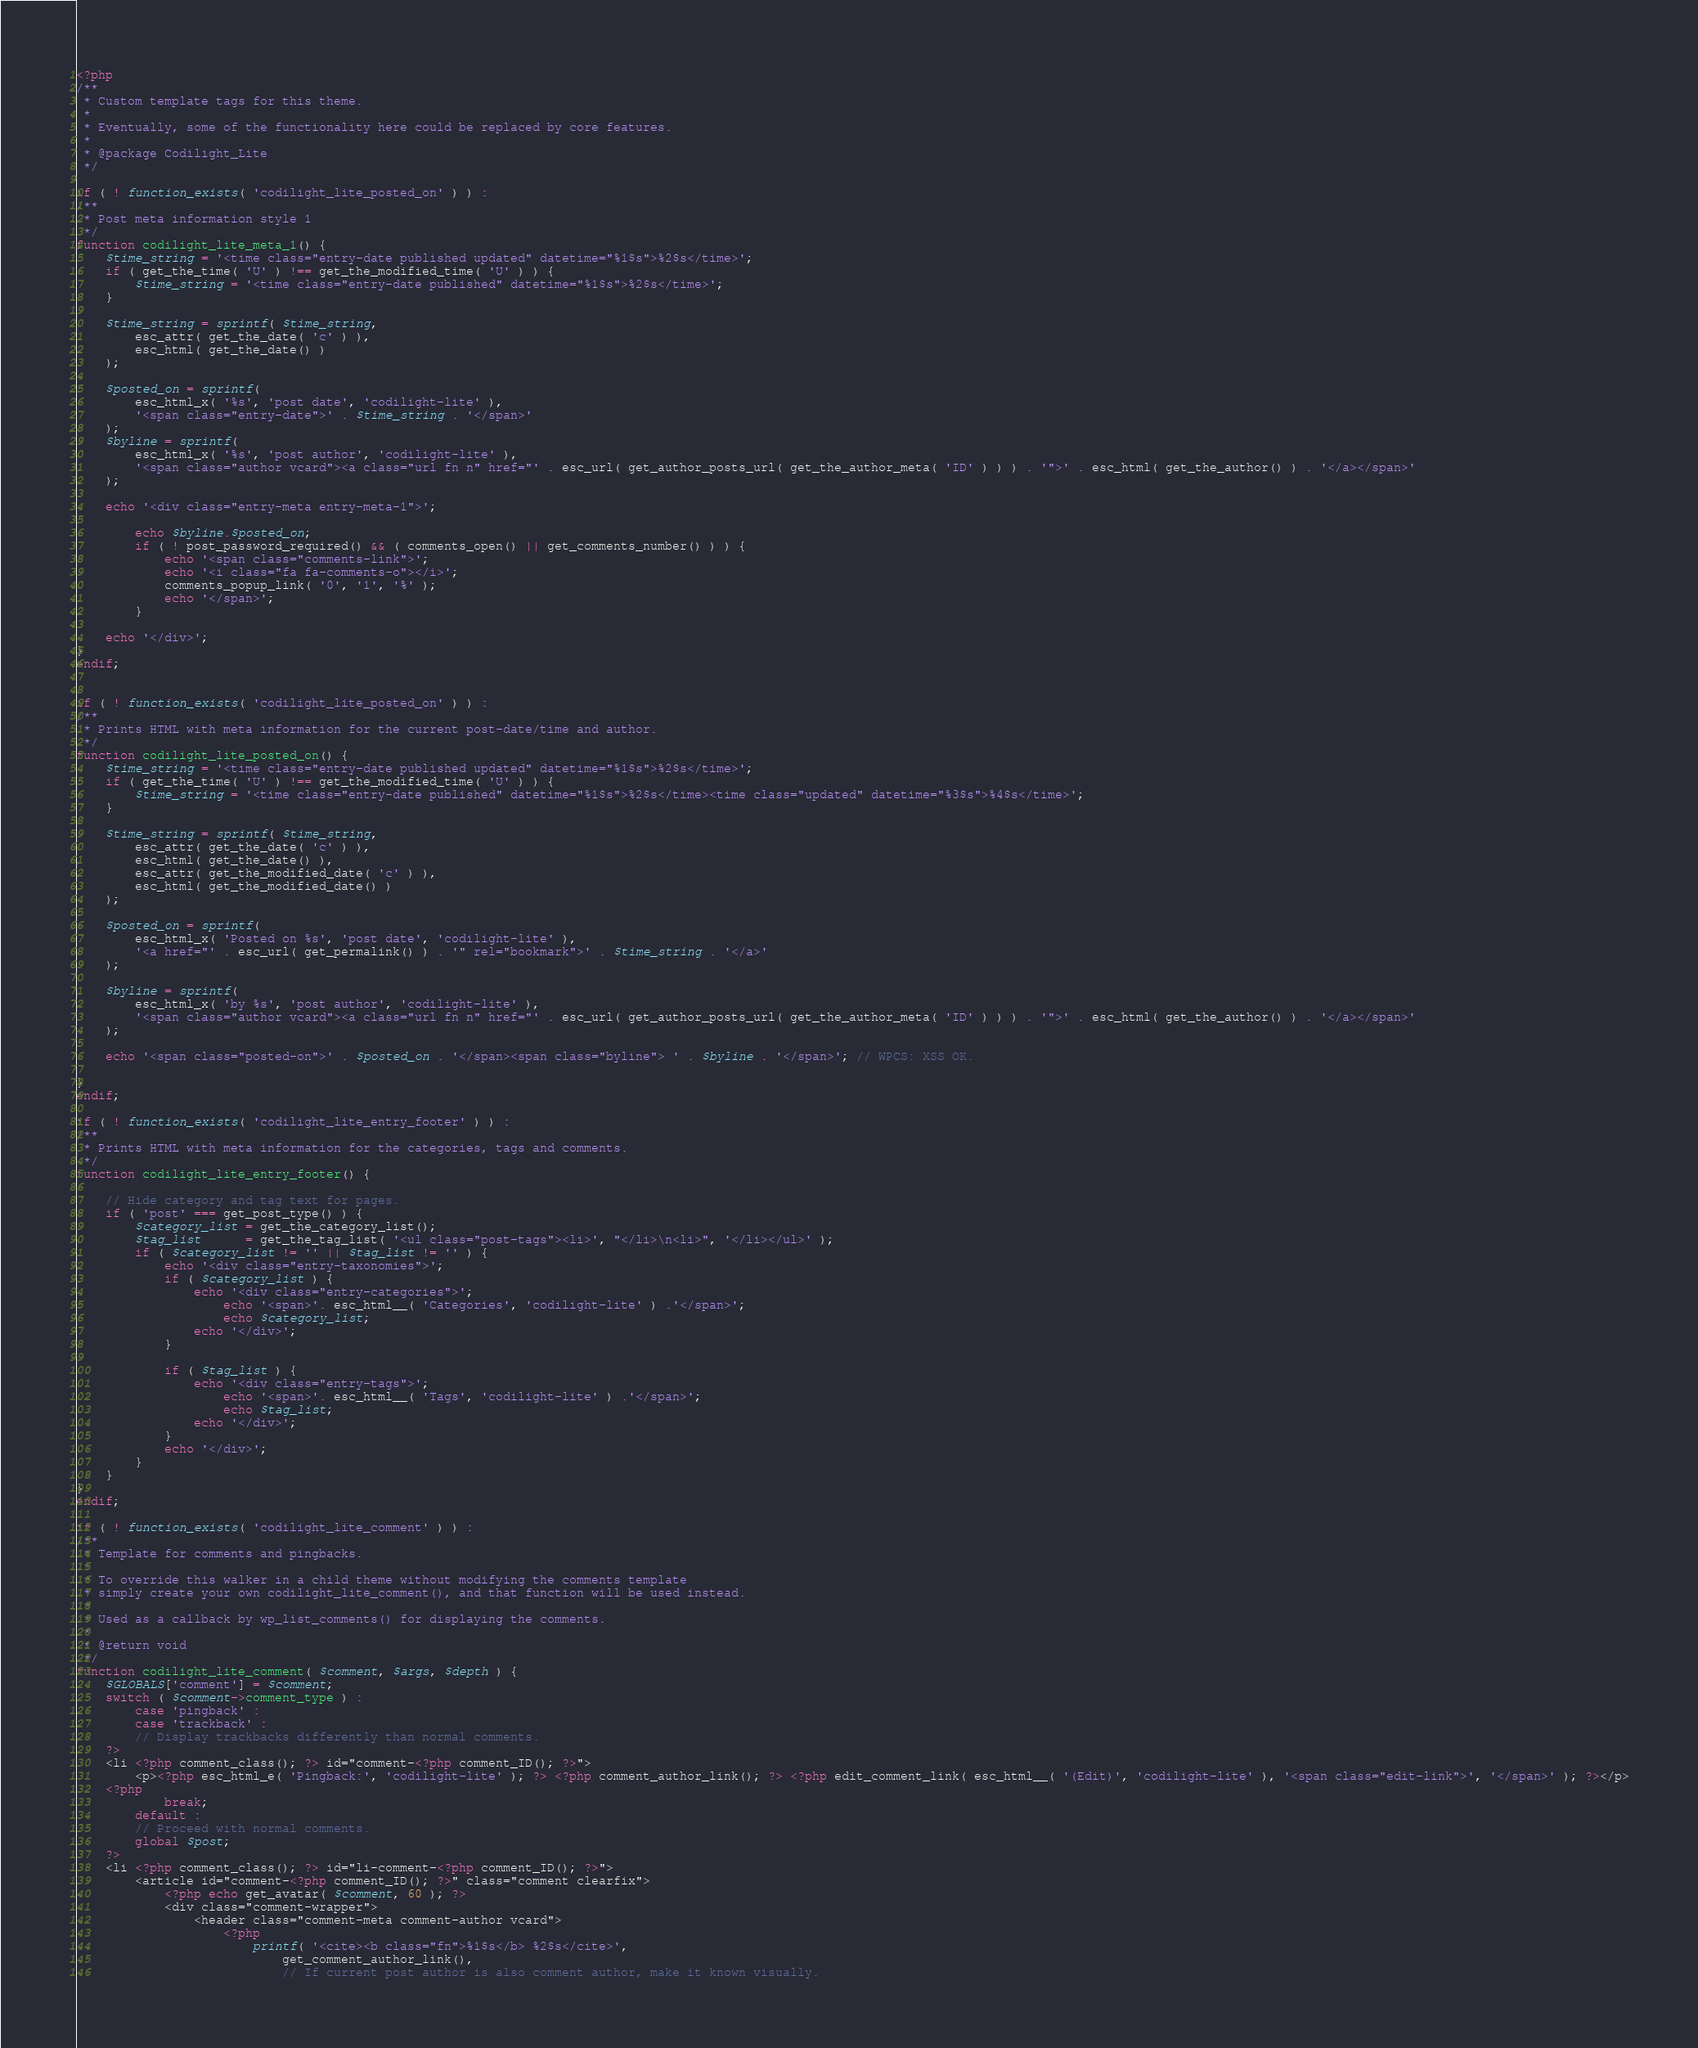Convert code to text. <code><loc_0><loc_0><loc_500><loc_500><_PHP_><?php
/**
 * Custom template tags for this theme.
 *
 * Eventually, some of the functionality here could be replaced by core features.
 *
 * @package Codilight_Lite
 */

if ( ! function_exists( 'codilight_lite_posted_on' ) ) :
/**
 * Post meta information style 1
 */
function codilight_lite_meta_1() {
	$time_string = '<time class="entry-date published updated" datetime="%1$s">%2$s</time>';
	if ( get_the_time( 'U' ) !== get_the_modified_time( 'U' ) ) {
		$time_string = '<time class="entry-date published" datetime="%1$s">%2$s</time>';
	}

	$time_string = sprintf( $time_string,
		esc_attr( get_the_date( 'c' ) ),
		esc_html( get_the_date() )
	);

	$posted_on = sprintf(
		esc_html_x( '%s', 'post date', 'codilight-lite' ),
		'<span class="entry-date">' . $time_string . '</span>'
	);
	$byline = sprintf(
		esc_html_x( '%s', 'post author', 'codilight-lite' ),
		'<span class="author vcard"><a class="url fn n" href="' . esc_url( get_author_posts_url( get_the_author_meta( 'ID' ) ) ) . '">' . esc_html( get_the_author() ) . '</a></span>'
	);

	echo '<div class="entry-meta entry-meta-1">';

		echo $byline.$posted_on;
		if ( ! post_password_required() && ( comments_open() || get_comments_number() ) ) {
			echo '<span class="comments-link">';
			echo '<i class="fa fa-comments-o"></i>';
			comments_popup_link( '0', '1', '%' );
			echo '</span>';
		}

	echo '</div>';
}
endif;


if ( ! function_exists( 'codilight_lite_posted_on' ) ) :
/**
 * Prints HTML with meta information for the current post-date/time and author.
 */
function codilight_lite_posted_on() {
	$time_string = '<time class="entry-date published updated" datetime="%1$s">%2$s</time>';
	if ( get_the_time( 'U' ) !== get_the_modified_time( 'U' ) ) {
		$time_string = '<time class="entry-date published" datetime="%1$s">%2$s</time><time class="updated" datetime="%3$s">%4$s</time>';
	}

	$time_string = sprintf( $time_string,
		esc_attr( get_the_date( 'c' ) ),
		esc_html( get_the_date() ),
		esc_attr( get_the_modified_date( 'c' ) ),
		esc_html( get_the_modified_date() )
	);

	$posted_on = sprintf(
		esc_html_x( 'Posted on %s', 'post date', 'codilight-lite' ),
		'<a href="' . esc_url( get_permalink() ) . '" rel="bookmark">' . $time_string . '</a>'
	);

	$byline = sprintf(
		esc_html_x( 'by %s', 'post author', 'codilight-lite' ),
		'<span class="author vcard"><a class="url fn n" href="' . esc_url( get_author_posts_url( get_the_author_meta( 'ID' ) ) ) . '">' . esc_html( get_the_author() ) . '</a></span>'
	);

	echo '<span class="posted-on">' . $posted_on . '</span><span class="byline"> ' . $byline . '</span>'; // WPCS: XSS OK.

}
endif;

if ( ! function_exists( 'codilight_lite_entry_footer' ) ) :
/**
 * Prints HTML with meta information for the categories, tags and comments.
 */
function codilight_lite_entry_footer() {

	// Hide category and tag text for pages.
	if ( 'post' === get_post_type() ) {
		$category_list = get_the_category_list();
		$tag_list      = get_the_tag_list( '<ul class="post-tags"><li>', "</li>\n<li>", '</li></ul>' );
		if ( $category_list != '' || $tag_list != '' ) {
			echo '<div class="entry-taxonomies">';
			if ( $category_list ) {
				echo '<div class="entry-categories">';
					echo '<span>'. esc_html__( 'Categories', 'codilight-lite' ) .'</span>';
					echo $category_list;
				echo '</div>';
			}

			if ( $tag_list ) {
				echo '<div class="entry-tags">';
					echo '<span>'. esc_html__( 'Tags', 'codilight-lite' ) .'</span>';
					echo $tag_list;
				echo '</div>';
			}
			echo '</div>';
		}
	}
}
endif;

if ( ! function_exists( 'codilight_lite_comment' ) ) :
/**
 * Template for comments and pingbacks.
 *
 * To override this walker in a child theme without modifying the comments template
 * simply create your own codilight_lite_comment(), and that function will be used instead.
 *
 * Used as a callback by wp_list_comments() for displaying the comments.
 *
 * @return void
 */
function codilight_lite_comment( $comment, $args, $depth ) {
    $GLOBALS['comment'] = $comment;
    switch ( $comment->comment_type ) :
        case 'pingback' :
        case 'trackback' :
        // Display trackbacks differently than normal comments.
    ?>
    <li <?php comment_class(); ?> id="comment-<?php comment_ID(); ?>">
        <p><?php esc_html_e( 'Pingback:', 'codilight-lite' ); ?> <?php comment_author_link(); ?> <?php edit_comment_link( esc_html__( '(Edit)', 'codilight-lite' ), '<span class="edit-link">', '</span>' ); ?></p>
    <?php
            break;
        default :
        // Proceed with normal comments.
        global $post;
    ?>
    <li <?php comment_class(); ?> id="li-comment-<?php comment_ID(); ?>">
        <article id="comment-<?php comment_ID(); ?>" class="comment clearfix">
            <?php echo get_avatar( $comment, 60 ); ?>
            <div class="comment-wrapper">
                <header class="comment-meta comment-author vcard">
                    <?php
                        printf( '<cite><b class="fn">%1$s</b> %2$s</cite>',
                            get_comment_author_link(),
                            // If current post author is also comment author, make it known visually.</code> 